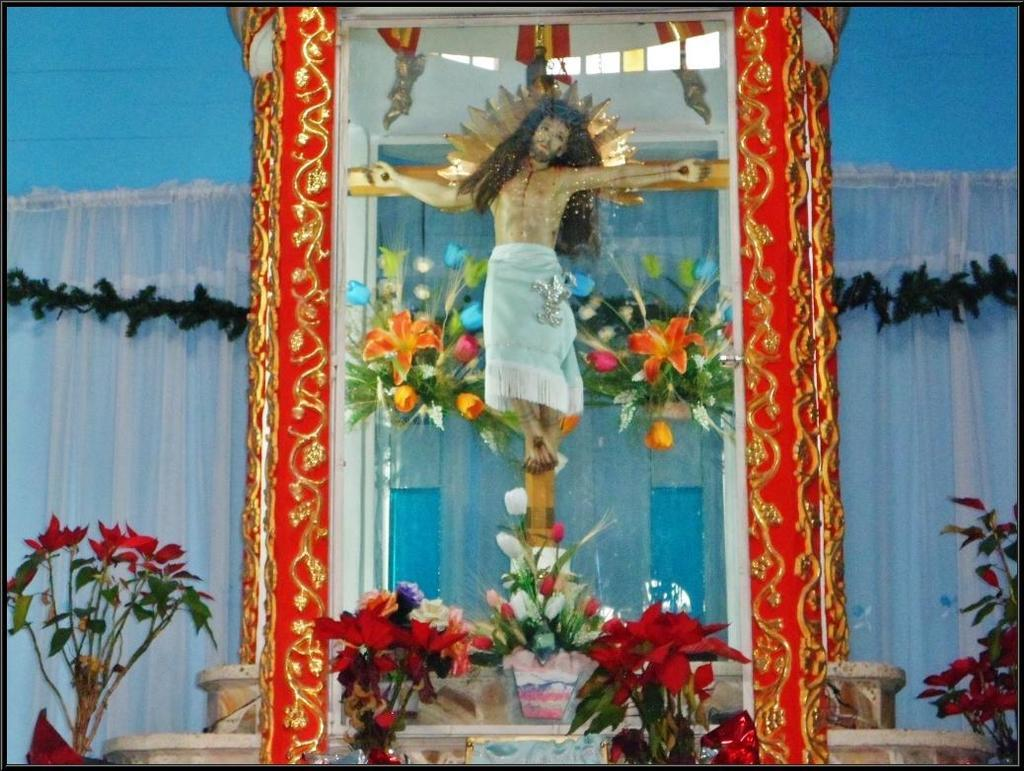What is the main subject of the image? There is an idol in the image. How is the idol displayed or protected? The idol is placed in a glass box. Are there any decorations or additional elements in the image? Yes, there are artificial flowers arranged around the idol. What is the middle of the bedroom like in the image? There is no bedroom or middle of a bedroom present in the image; it features an idol placed in a glass box with artificial flowers arranged around it. 